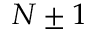Convert formula to latex. <formula><loc_0><loc_0><loc_500><loc_500>N \pm 1</formula> 